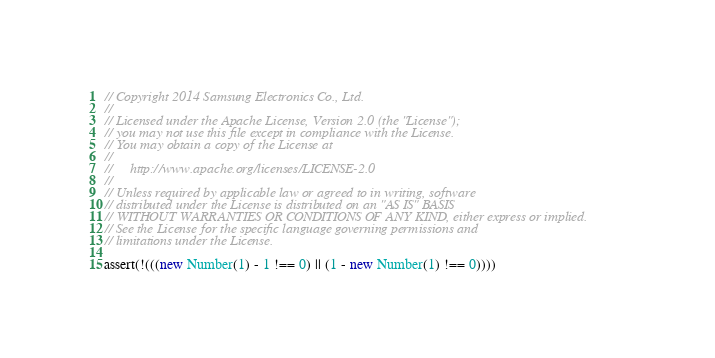<code> <loc_0><loc_0><loc_500><loc_500><_JavaScript_>// Copyright 2014 Samsung Electronics Co., Ltd.
//
// Licensed under the Apache License, Version 2.0 (the "License");
// you may not use this file except in compliance with the License.
// You may obtain a copy of the License at
//
//     http://www.apache.org/licenses/LICENSE-2.0
//
// Unless required by applicable law or agreed to in writing, software
// distributed under the License is distributed on an "AS IS" BASIS
// WITHOUT WARRANTIES OR CONDITIONS OF ANY KIND, either express or implied.
// See the License for the specific language governing permissions and
// limitations under the License.

assert(!(((new Number(1) - 1 !== 0) || (1 - new Number(1) !== 0))))</code> 